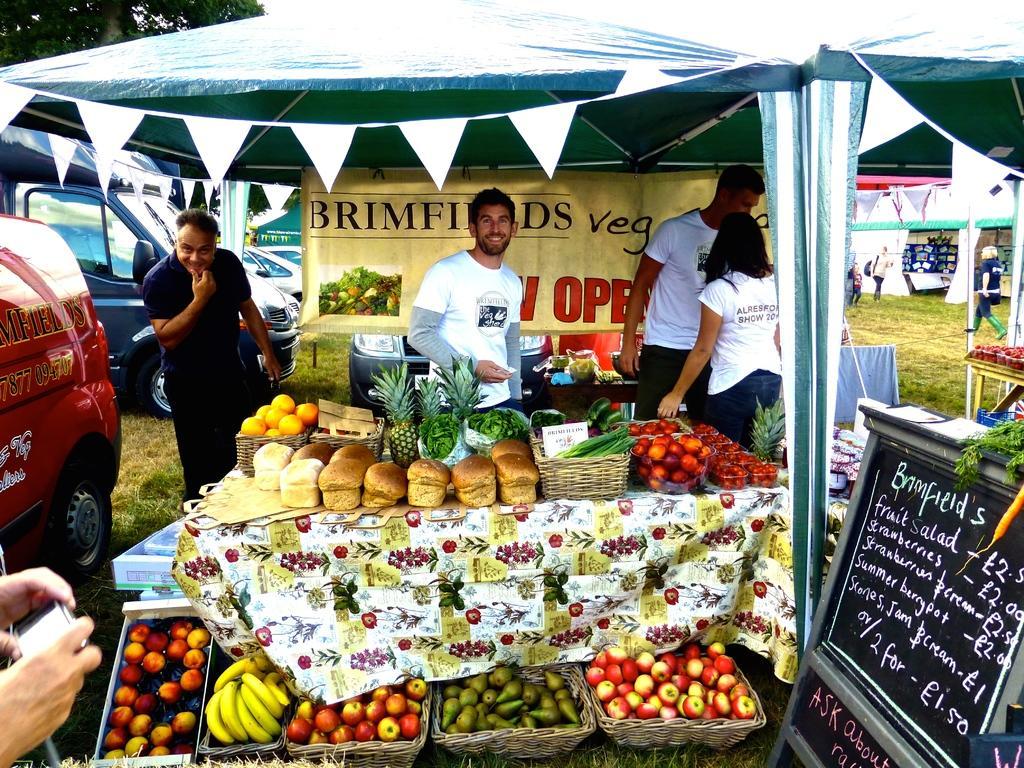Please provide a concise description of this image. In this image, in the left corner, we can see the hand of a person holding a camera. On the left side, we can see a car. On the right side, we can see a black color board with some text written on it. On the right side, we can see a tent and a group of people are walking on the grass and some vegetables which are placed on the table. In the middle of the image, we can see a group of people are standing in front of the table, on the table, we can see some vegetables and fruits. In the background, we can see some hoardings with some pictures and text written on it. At the top, we can see some tent, flags. In the background, we can also see another vehicle, trees, at the bottom, we can see a grass. 